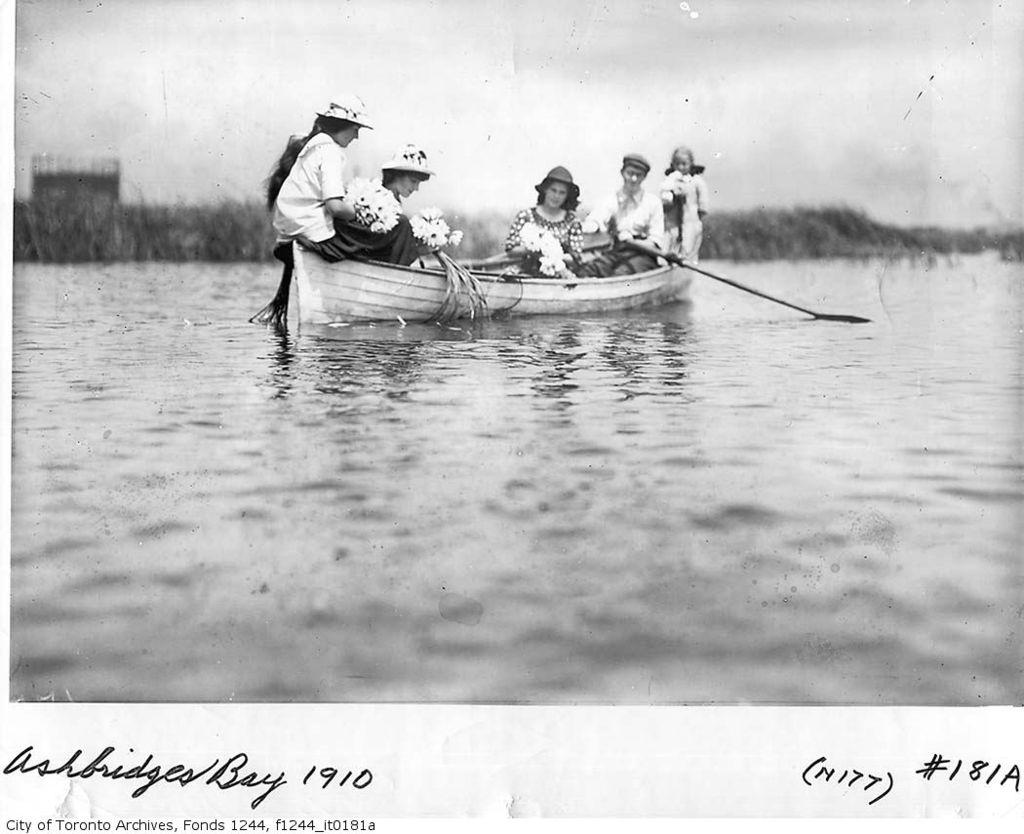What is happening in the foreground of the image? There is a group of people in the foreground of the image. What are the people in the image doing? The group of people are boating in the water. What can be seen in the background of the image? There are plants visible in the background of the image. What is visible at the top of the image? The sky is visible at the top of the image. What might be the location of the image? The image may have been taken at a lake. What type of curve can be seen in the image? There is no curve present in the image; it features a group of people boating in the water. How many stars are visible in the image? There are no stars visible in the image, as it is taken during the daytime. 